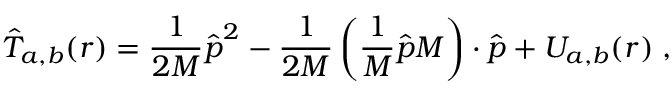Convert formula to latex. <formula><loc_0><loc_0><loc_500><loc_500>\hat { T } _ { a , b } ( r ) = \frac { 1 } { 2 M } \hat { p } ^ { 2 } - \frac { 1 } { 2 M } \left ( \frac { 1 } { M } \hat { p } M \right ) \cdot \hat { p } + U _ { a , b } ( r ) \, ,</formula> 